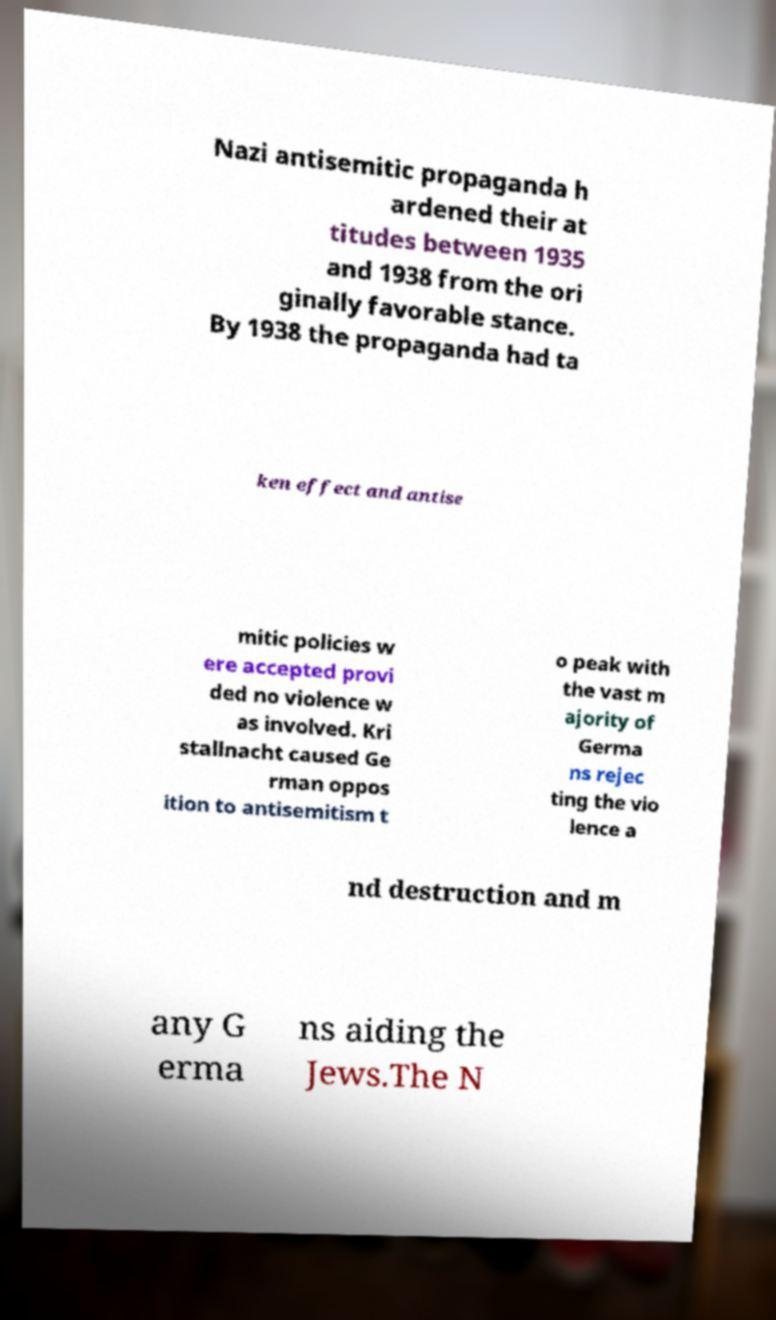There's text embedded in this image that I need extracted. Can you transcribe it verbatim? Nazi antisemitic propaganda h ardened their at titudes between 1935 and 1938 from the ori ginally favorable stance. By 1938 the propaganda had ta ken effect and antise mitic policies w ere accepted provi ded no violence w as involved. Kri stallnacht caused Ge rman oppos ition to antisemitism t o peak with the vast m ajority of Germa ns rejec ting the vio lence a nd destruction and m any G erma ns aiding the Jews.The N 